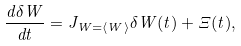<formula> <loc_0><loc_0><loc_500><loc_500>\frac { d \delta W } { d t } = J _ { W = \langle W \rangle } \delta W ( t ) + \Xi ( t ) ,</formula> 